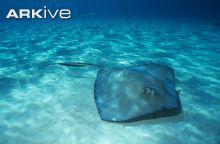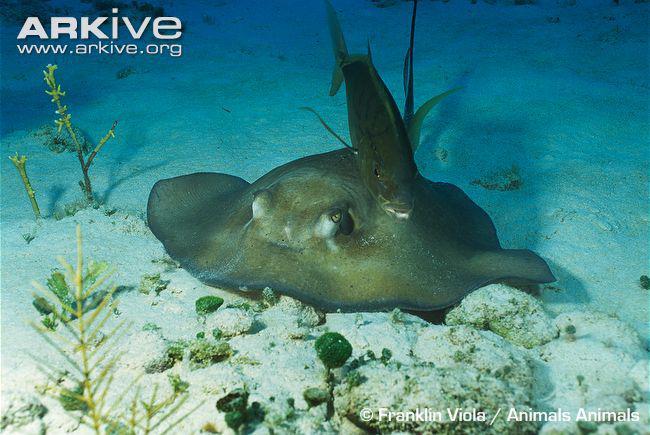The first image is the image on the left, the second image is the image on the right. Analyze the images presented: Is the assertion "There's a blue ray and a brown/grey ray, swimming over smooth sand." valid? Answer yes or no. No. The first image is the image on the left, the second image is the image on the right. Considering the images on both sides, is "An image shows one stingray facing rightward, which is not covered with sand." valid? Answer yes or no. Yes. 